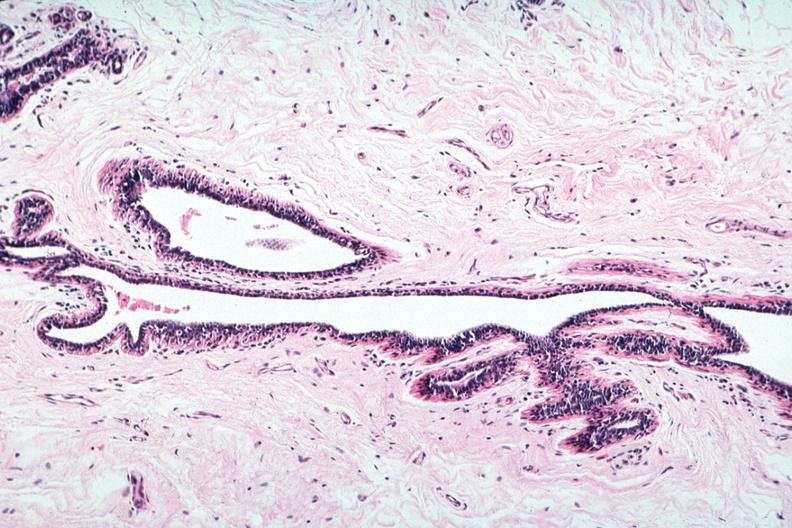what is present?
Answer the question using a single word or phrase. Breast 